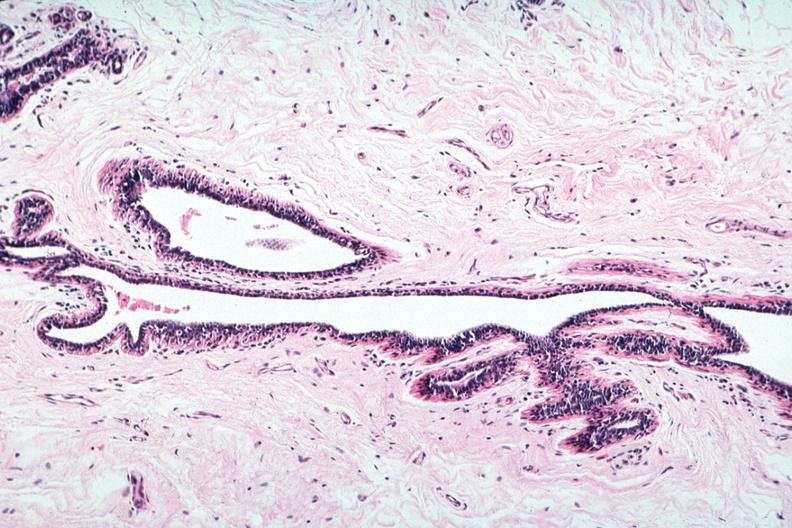what is present?
Answer the question using a single word or phrase. Breast 